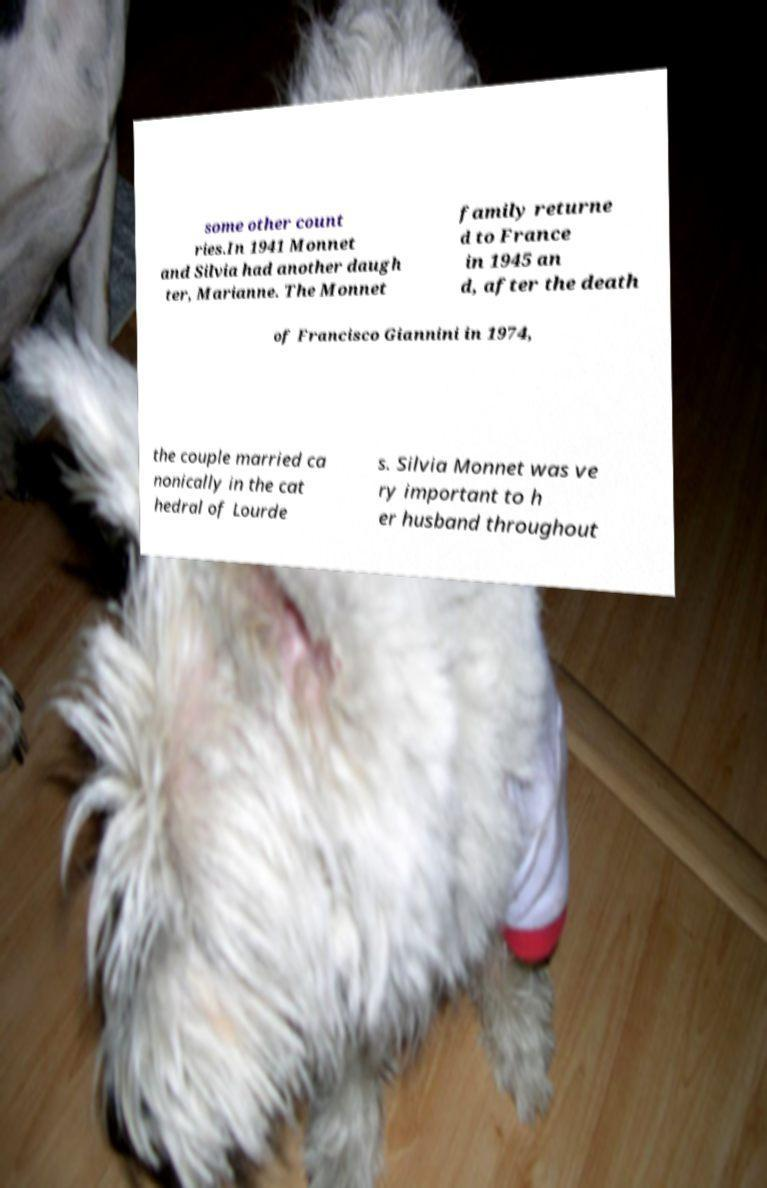What messages or text are displayed in this image? I need them in a readable, typed format. some other count ries.In 1941 Monnet and Silvia had another daugh ter, Marianne. The Monnet family returne d to France in 1945 an d, after the death of Francisco Giannini in 1974, the couple married ca nonically in the cat hedral of Lourde s. Silvia Monnet was ve ry important to h er husband throughout 